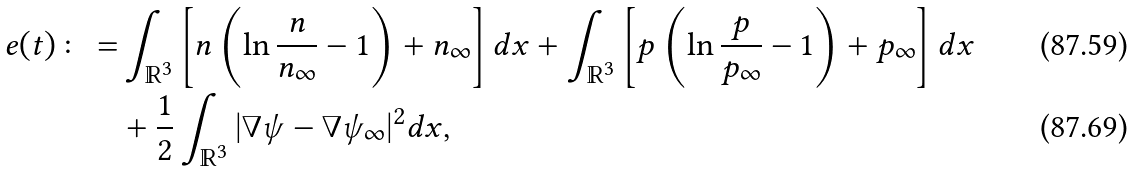<formula> <loc_0><loc_0><loc_500><loc_500>e ( t ) \colon = & \int _ { \mathbb { R } ^ { 3 } } \left [ n \left ( \ln \frac { n } { n _ { \infty } } - 1 \right ) + n _ { \infty } \right ] d x + \int _ { \mathbb { R } ^ { 3 } } \left [ p \left ( \ln \frac { p } { p _ { \infty } } - 1 \right ) + p _ { \infty } \right ] d x \\ & + \frac { 1 } { 2 } \int _ { \mathbb { R } ^ { 3 } } | \nabla \psi - \nabla \psi _ { \infty } | ^ { 2 } d x ,</formula> 